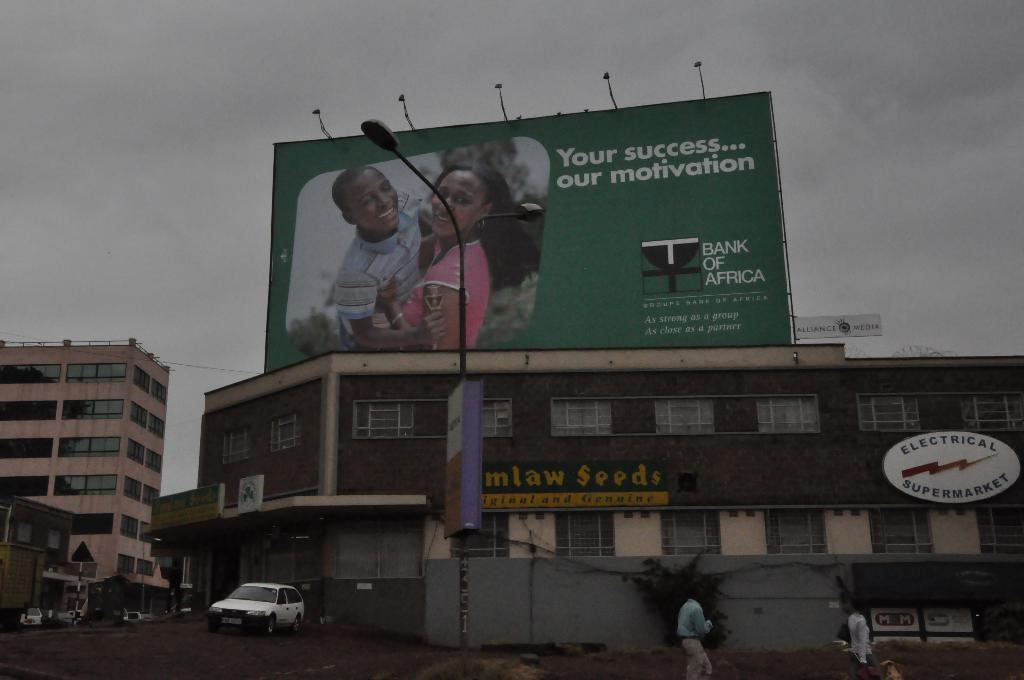What bank sponsored the board?
Your answer should be very brief. Bank of africa. 